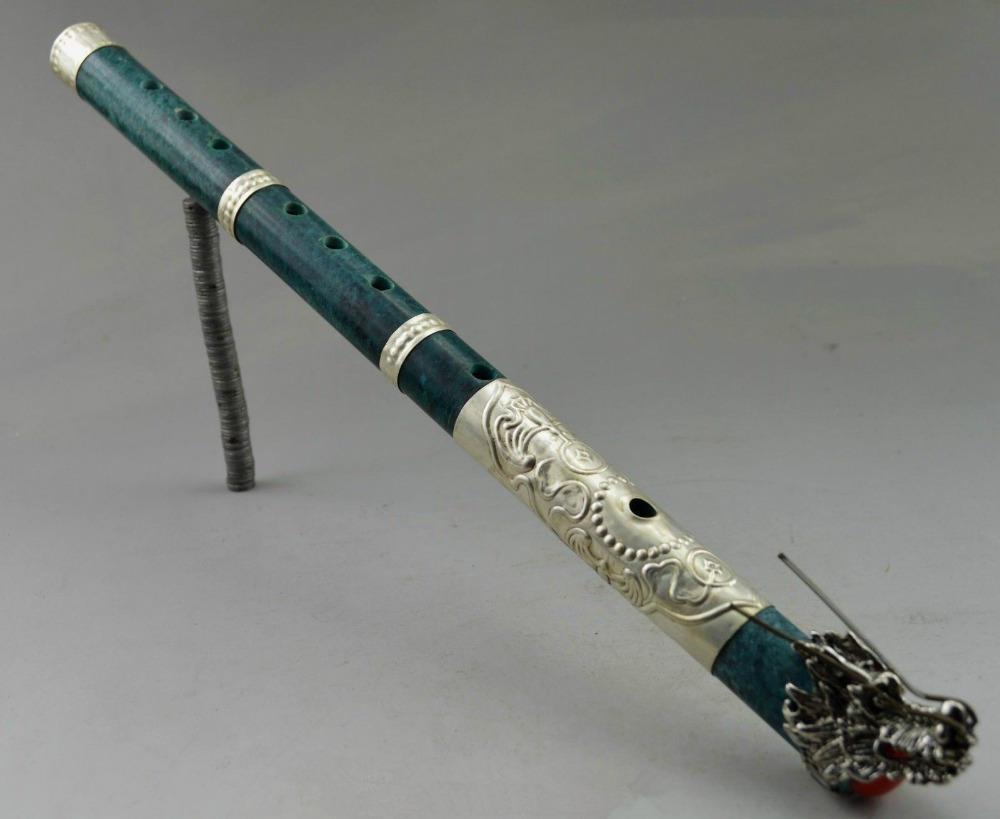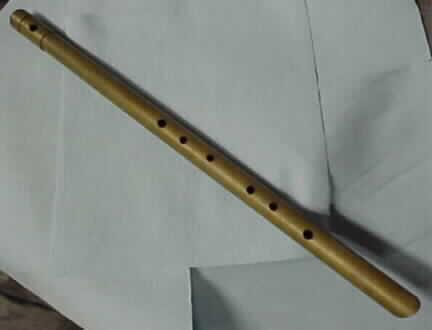The first image is the image on the left, the second image is the image on the right. Examine the images to the left and right. Is the description "Both flutes are brown and presumably wooden, with little to no decoration." accurate? Answer yes or no. No. The first image is the image on the left, the second image is the image on the right. Given the left and right images, does the statement "There are a total of two flutes facing opposite directions." hold true? Answer yes or no. No. 